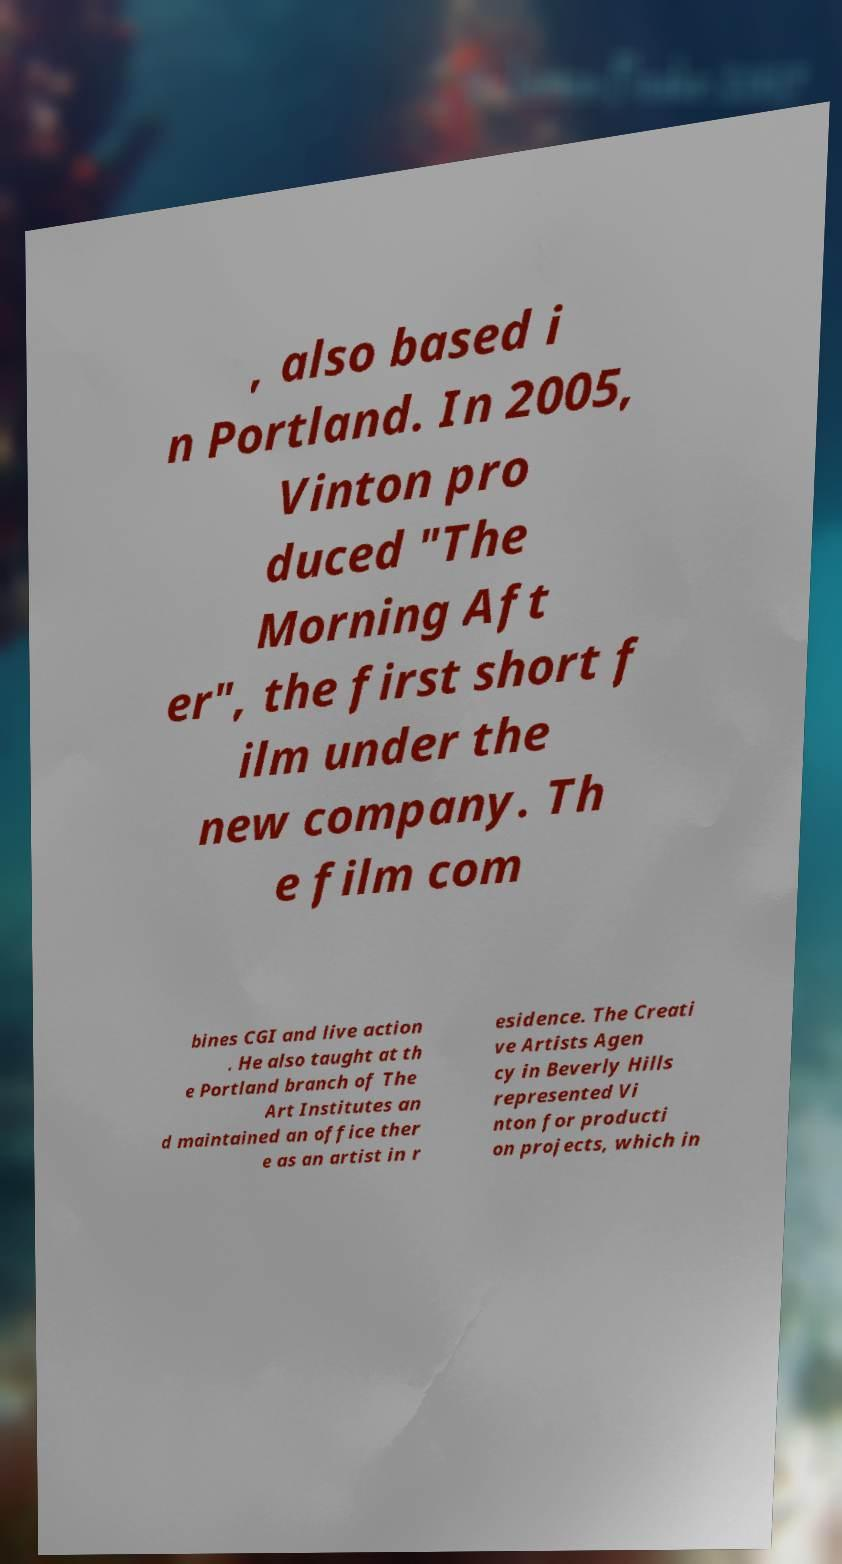For documentation purposes, I need the text within this image transcribed. Could you provide that? , also based i n Portland. In 2005, Vinton pro duced "The Morning Aft er", the first short f ilm under the new company. Th e film com bines CGI and live action . He also taught at th e Portland branch of The Art Institutes an d maintained an office ther e as an artist in r esidence. The Creati ve Artists Agen cy in Beverly Hills represented Vi nton for producti on projects, which in 